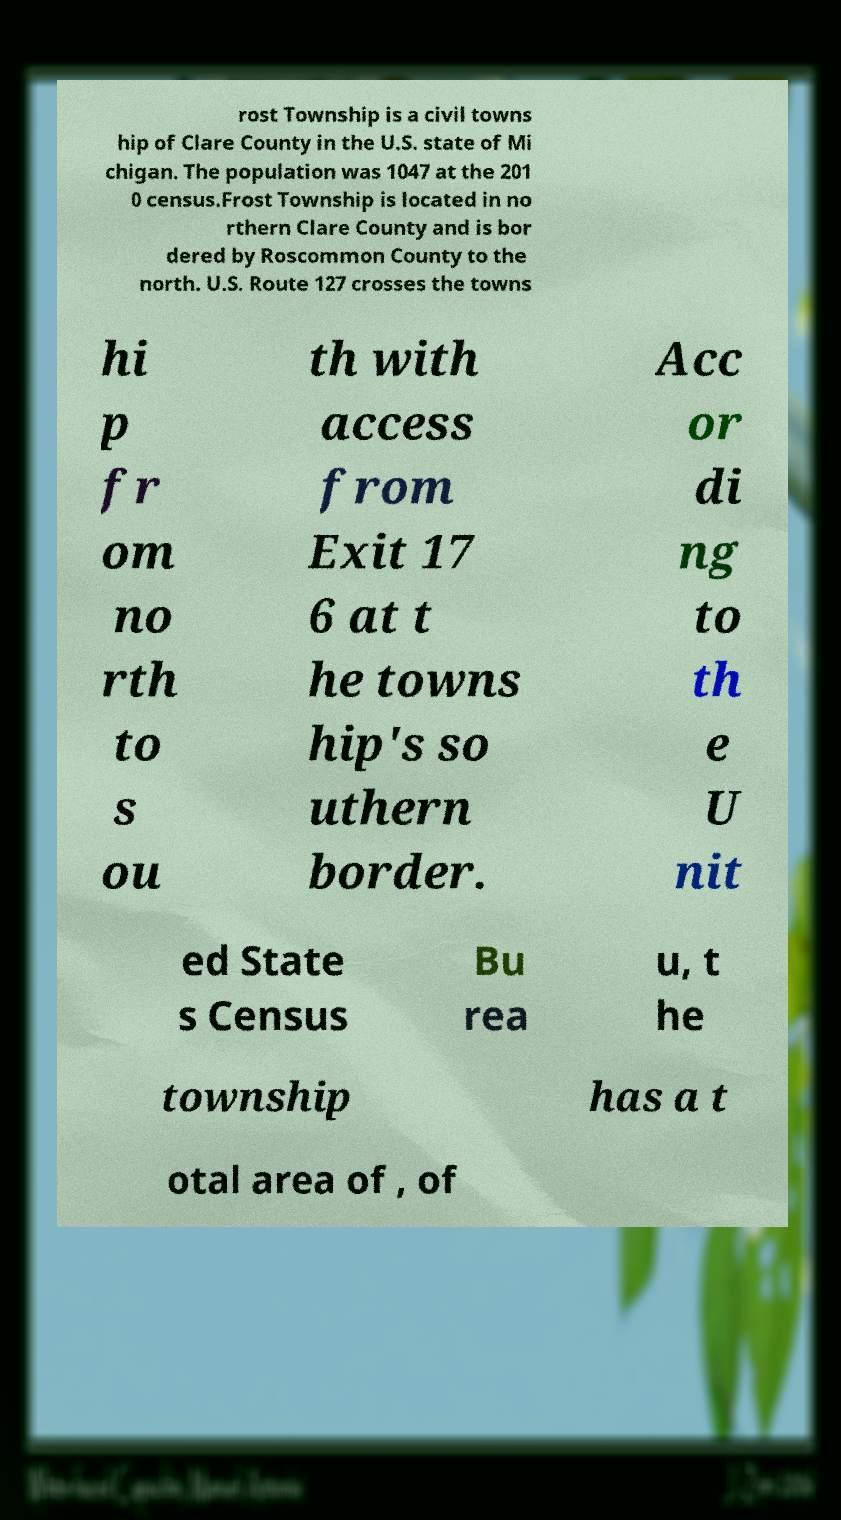Could you extract and type out the text from this image? rost Township is a civil towns hip of Clare County in the U.S. state of Mi chigan. The population was 1047 at the 201 0 census.Frost Township is located in no rthern Clare County and is bor dered by Roscommon County to the north. U.S. Route 127 crosses the towns hi p fr om no rth to s ou th with access from Exit 17 6 at t he towns hip's so uthern border. Acc or di ng to th e U nit ed State s Census Bu rea u, t he township has a t otal area of , of 